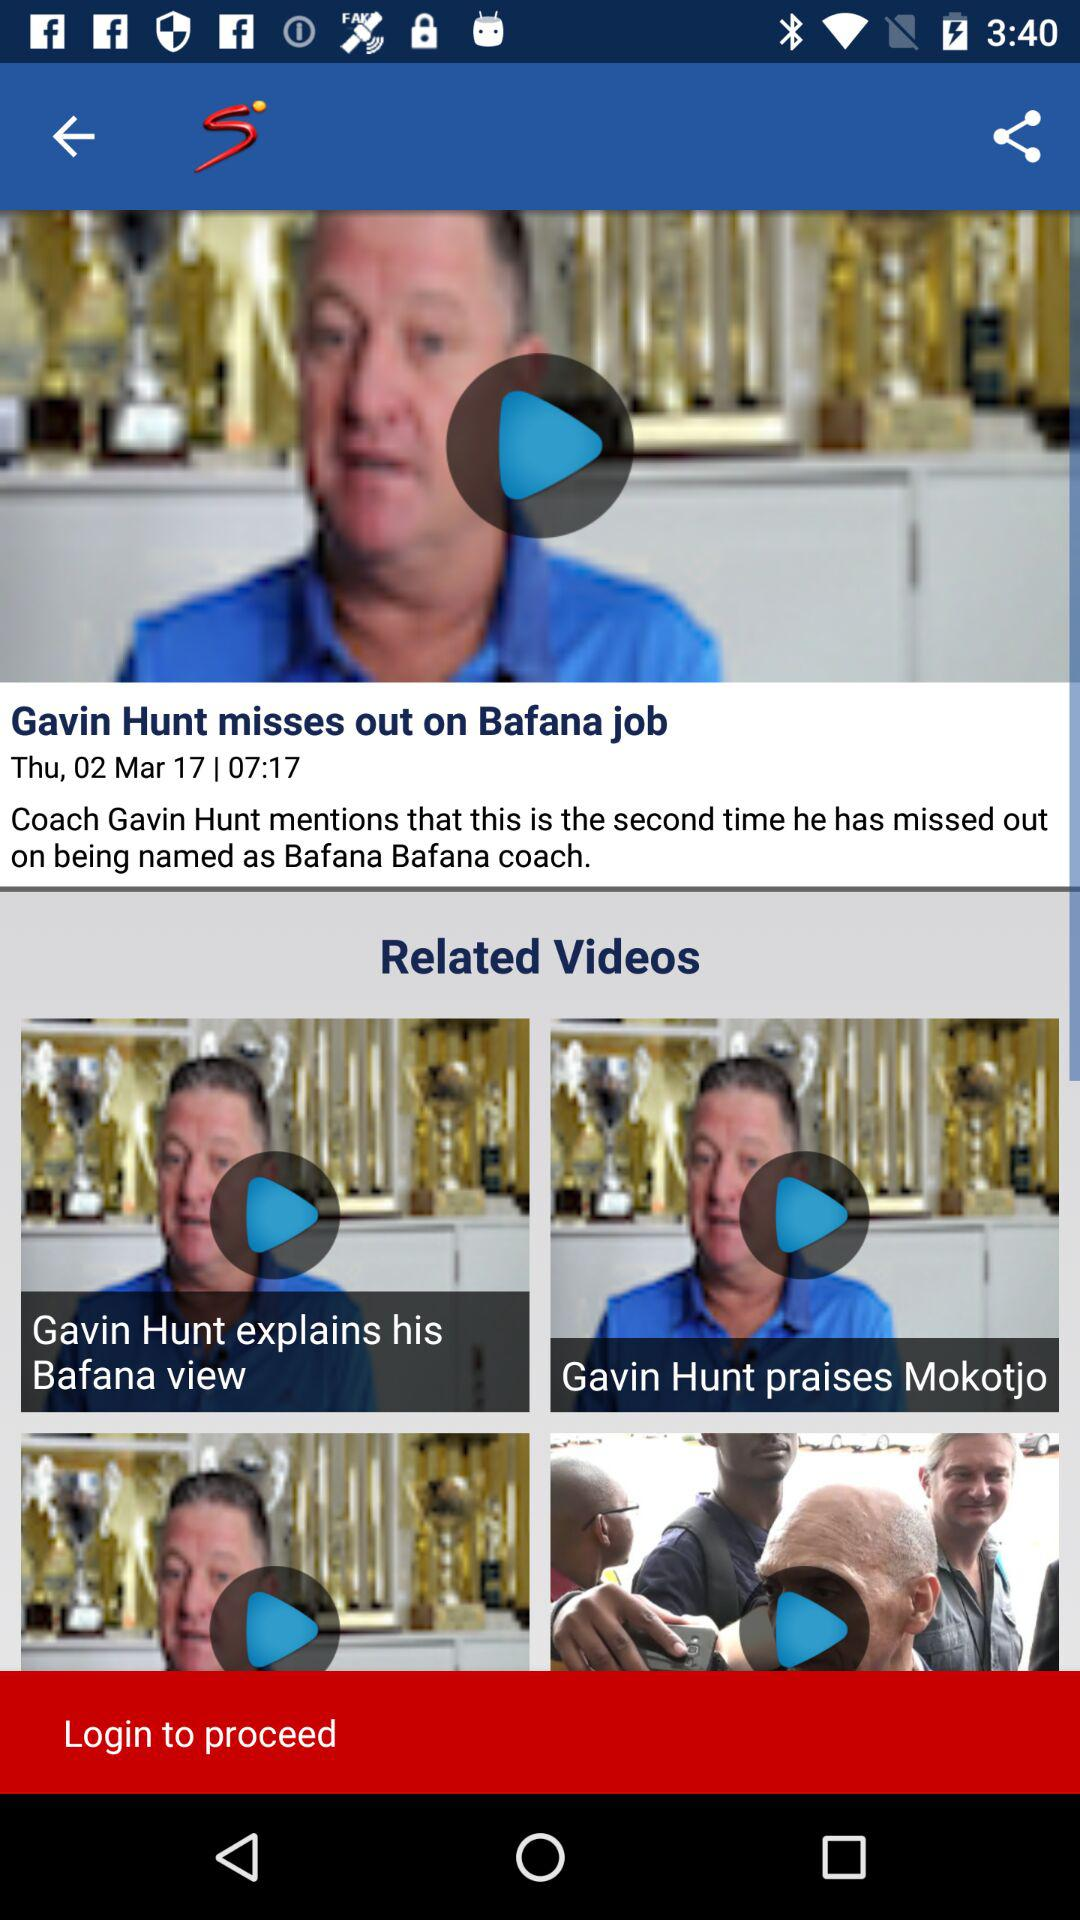At what time was the news posted? The news was posted at 7:17. 